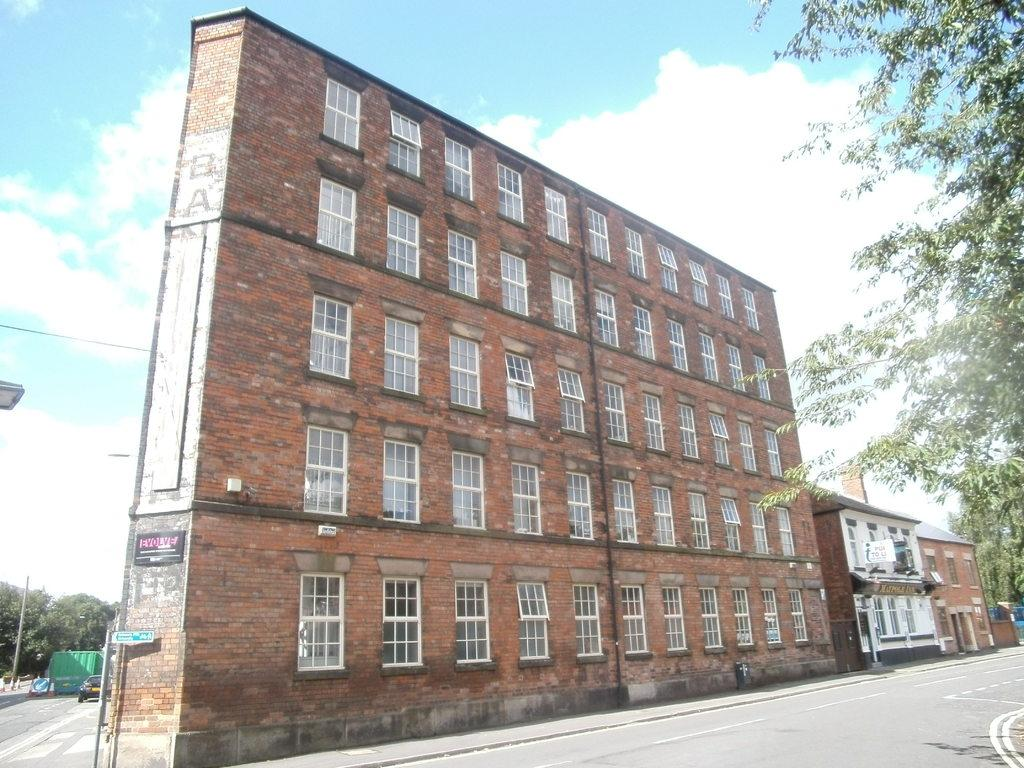What type of structures can be seen in the image? There are buildings with windows in the image. What other elements are present in the image besides buildings? There are trees and a car on the road in the image. What can be seen in the background of the image? The sky is visible in the background of the image. What is the condition of the sky in the image? Clouds are present in the sky. What type of appliance is hanging from the tree in the image? There is no appliance hanging from the tree in the image; only buildings, trees, a car, and the sky are present. 